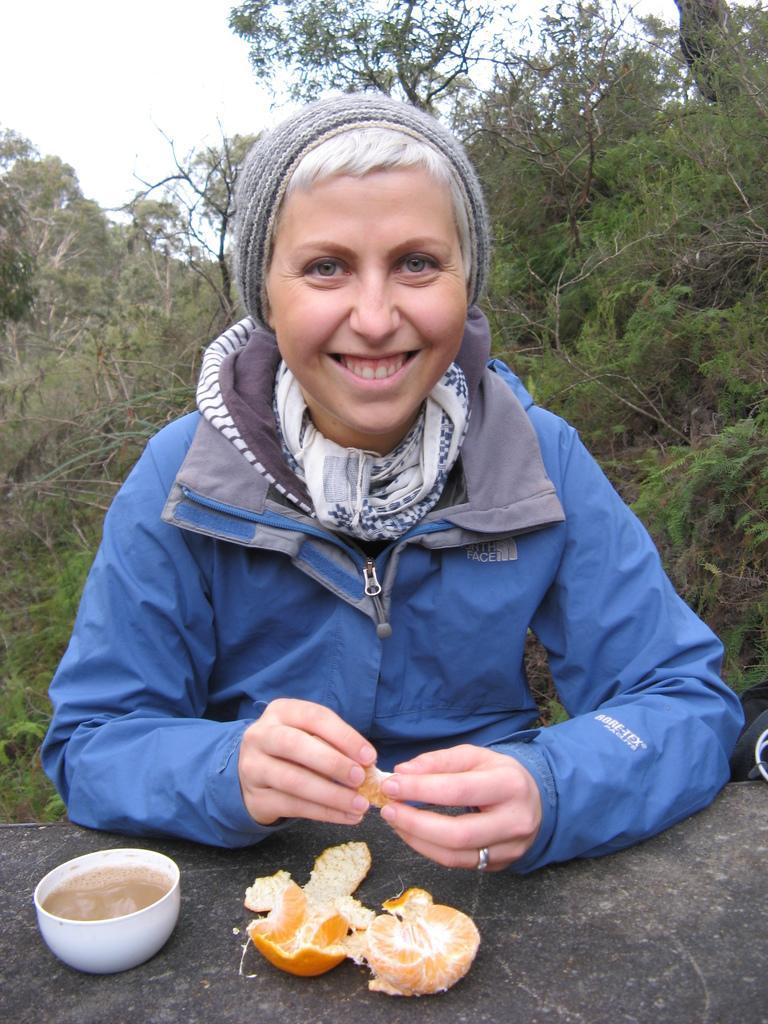How would you summarize this image in a sentence or two? In this picture we can see a woman wearing a jacket, cap and smiling, cup with drink in it, orange and these two are placed on a rock and in the background we can see trees, sky. 